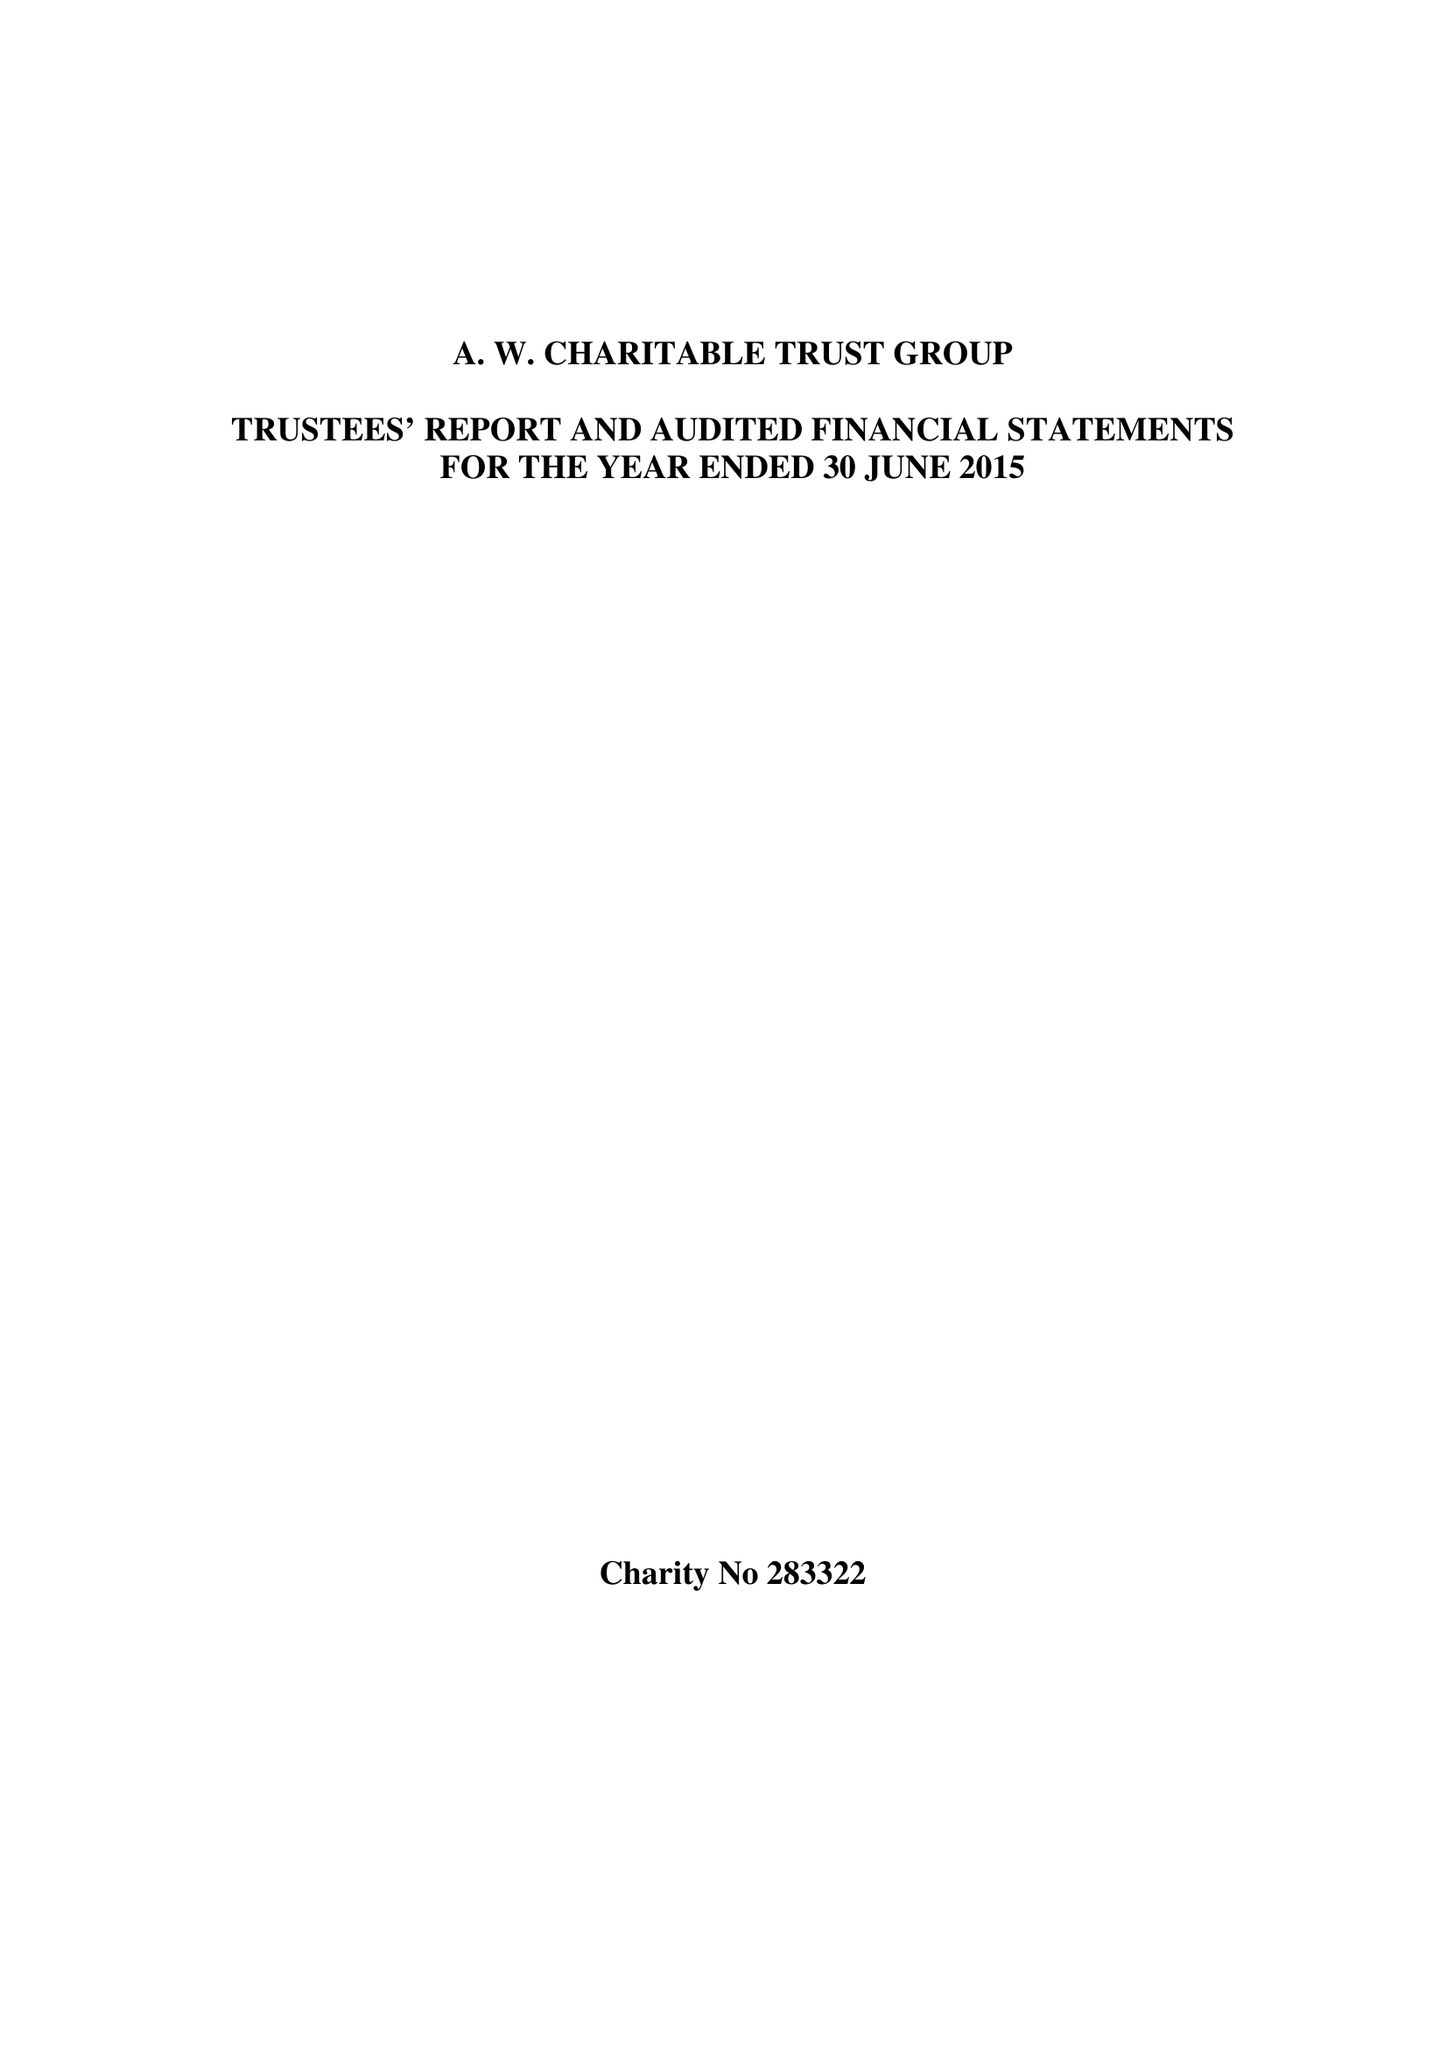What is the value for the address__postcode?
Answer the question using a single word or phrase. M7 4JL 